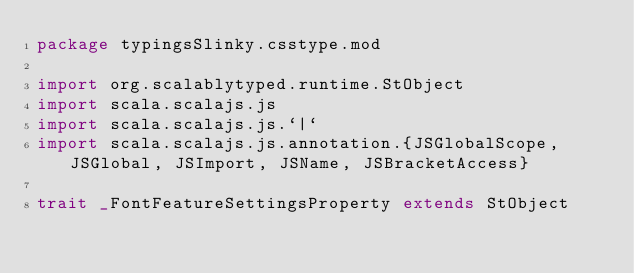<code> <loc_0><loc_0><loc_500><loc_500><_Scala_>package typingsSlinky.csstype.mod

import org.scalablytyped.runtime.StObject
import scala.scalajs.js
import scala.scalajs.js.`|`
import scala.scalajs.js.annotation.{JSGlobalScope, JSGlobal, JSImport, JSName, JSBracketAccess}

trait _FontFeatureSettingsProperty extends StObject
</code> 